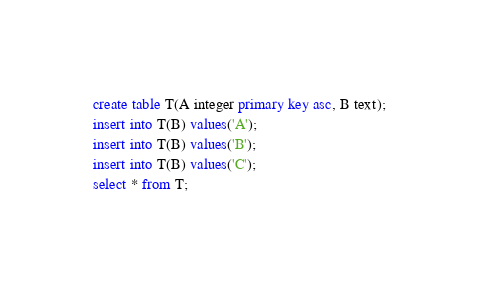<code> <loc_0><loc_0><loc_500><loc_500><_SQL_>create table T(A integer primary key asc, B text);
insert into T(B) values('A');
insert into T(B) values('B');
insert into T(B) values('C');
select * from T;

</code> 